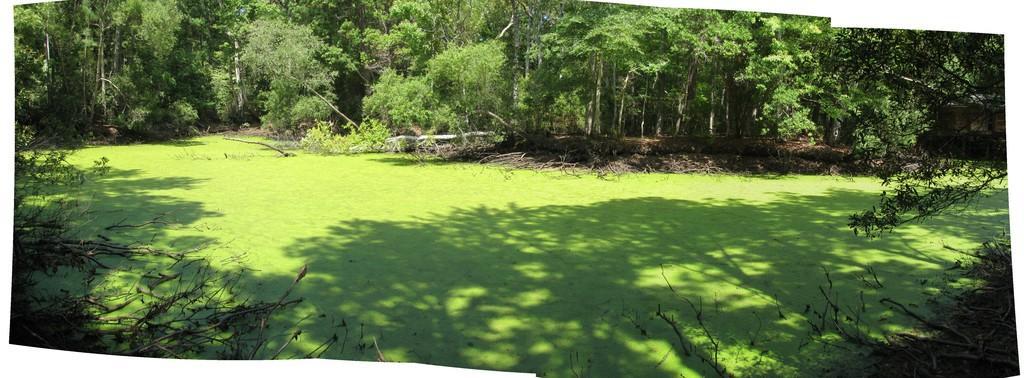How would you summarize this image in a sentence or two? In this image in the front there are dry branches of a tree. In the center there is grass on the ground. In the background there are trees and there are dry leaves. 